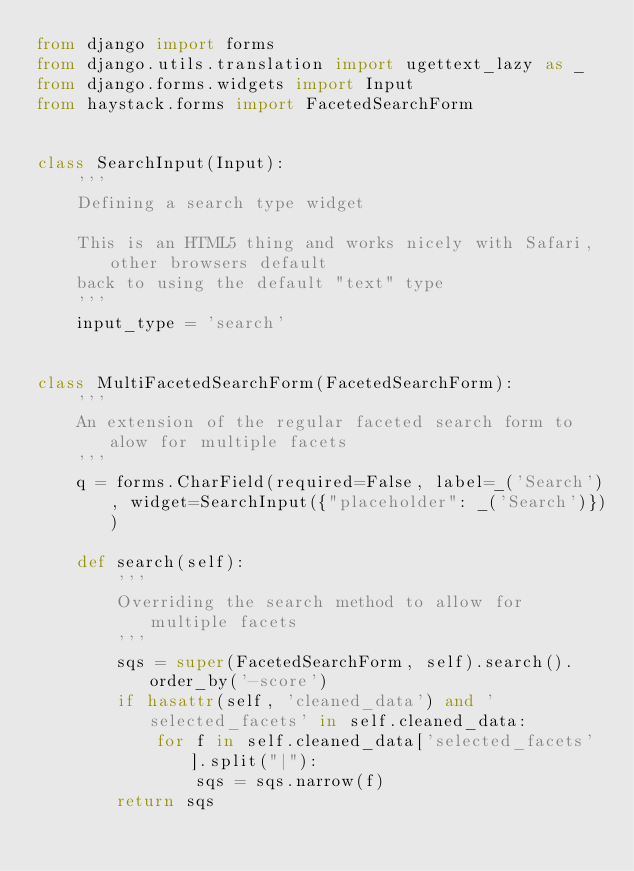<code> <loc_0><loc_0><loc_500><loc_500><_Python_>from django import forms
from django.utils.translation import ugettext_lazy as _
from django.forms.widgets import Input
from haystack.forms import FacetedSearchForm


class SearchInput(Input):
    '''
    Defining a search type widget

    This is an HTML5 thing and works nicely with Safari, other browsers default
    back to using the default "text" type
    '''
    input_type = 'search'


class MultiFacetedSearchForm(FacetedSearchForm):
    '''
    An extension of the regular faceted search form to alow for multiple facets
    '''
    q = forms.CharField(required=False, label=_('Search'), widget=SearchInput({"placeholder": _('Search')}))

    def search(self):
        '''
        Overriding the search method to allow for multiple facets
        '''
        sqs = super(FacetedSearchForm, self).search().order_by('-score')
        if hasattr(self, 'cleaned_data') and 'selected_facets' in self.cleaned_data:
            for f in self.cleaned_data['selected_facets'].split("|"):
                sqs = sqs.narrow(f)
        return sqs</code> 